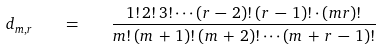Convert formula to latex. <formula><loc_0><loc_0><loc_500><loc_500>d _ { m , r } \quad = \quad \frac { 1 ! \, 2 ! \, 3 ! \cdots ( r \, - \, 2 ) ! \, ( r \, - \, 1 ) ! \cdot ( m r ) ! } { m ! \, ( m \, + \, 1 ) ! \, ( m \, + \, 2 ) ! \cdots ( m \, + \, r \, - \, 1 ) ! }</formula> 